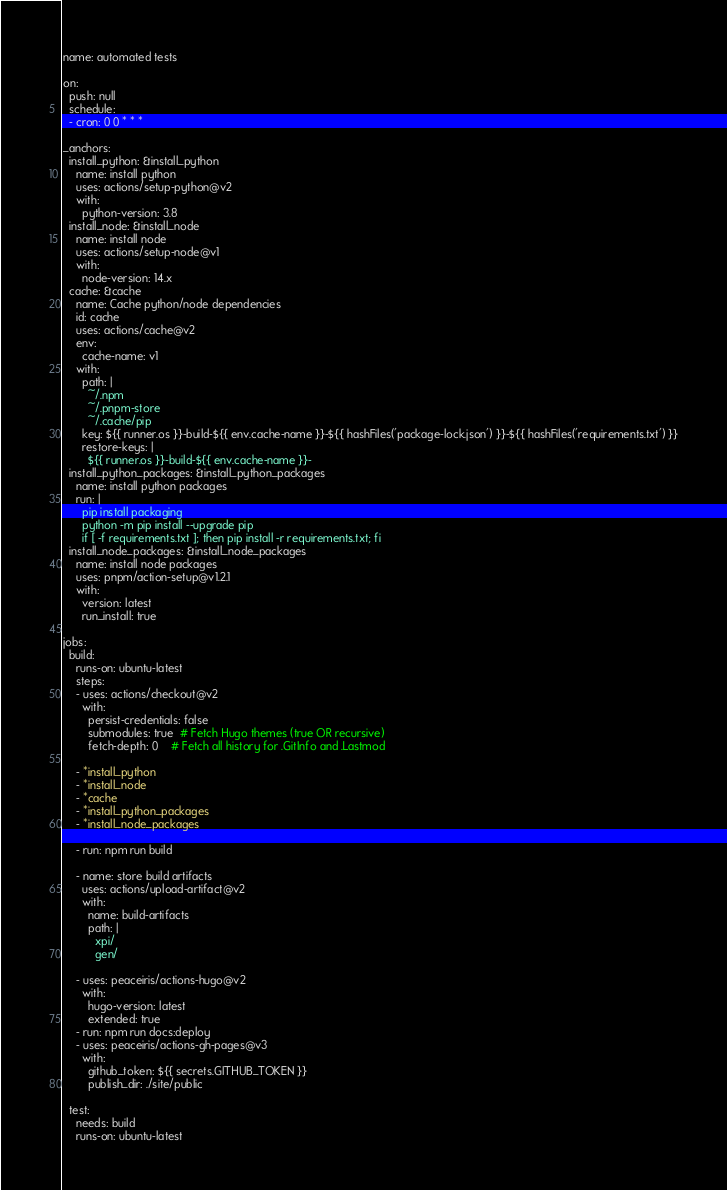Convert code to text. <code><loc_0><loc_0><loc_500><loc_500><_YAML_>name: automated tests

on:
  push: null
  schedule:
  - cron: 0 0 * * *

_anchors:
  install_python: &install_python
    name: install python
    uses: actions/setup-python@v2
    with:
      python-version: 3.8
  install_node: &install_node
    name: install node
    uses: actions/setup-node@v1
    with:
      node-version: 14.x
  cache: &cache
    name: Cache python/node dependencies
    id: cache
    uses: actions/cache@v2
    env:
      cache-name: v1
    with:
      path: |
        ~/.npm
        ~/.pnpm-store
        ~/.cache/pip
      key: ${{ runner.os }}-build-${{ env.cache-name }}-${{ hashFiles('package-lock.json') }}-${{ hashFiles('requirements.txt') }}
      restore-keys: |
        ${{ runner.os }}-build-${{ env.cache-name }}-
  install_python_packages: &install_python_packages
    name: install python packages
    run: |
      pip install packaging
      python -m pip install --upgrade pip
      if [ -f requirements.txt ]; then pip install -r requirements.txt; fi
  install_node_packages: &install_node_packages
    name: install node packages
    uses: pnpm/action-setup@v1.2.1
    with:
      version: latest
      run_install: true

jobs:
  build:
    runs-on: ubuntu-latest
    steps:
    - uses: actions/checkout@v2
      with:
        persist-credentials: false
        submodules: true  # Fetch Hugo themes (true OR recursive)
        fetch-depth: 0    # Fetch all history for .GitInfo and .Lastmod

    - *install_python
    - *install_node
    - *cache
    - *install_python_packages
    - *install_node_packages

    - run: npm run build

    - name: store build artifacts
      uses: actions/upload-artifact@v2
      with:
        name: build-artifacts
        path: |
          xpi/
          gen/

    - uses: peaceiris/actions-hugo@v2
      with:
        hugo-version: latest
        extended: true
    - run: npm run docs:deploy
    - uses: peaceiris/actions-gh-pages@v3
      with:
        github_token: ${{ secrets.GITHUB_TOKEN }}
        publish_dir: ./site/public

  test:
    needs: build
    runs-on: ubuntu-latest</code> 